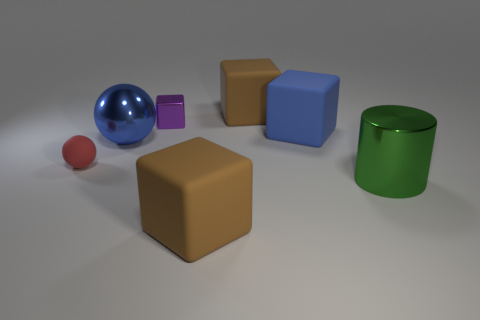Add 1 tiny red rubber spheres. How many objects exist? 8 Subtract all balls. How many objects are left? 5 Add 3 small shiny objects. How many small shiny objects are left? 4 Add 7 brown cylinders. How many brown cylinders exist? 7 Subtract 0 gray spheres. How many objects are left? 7 Subtract all red matte balls. Subtract all big cyan shiny spheres. How many objects are left? 6 